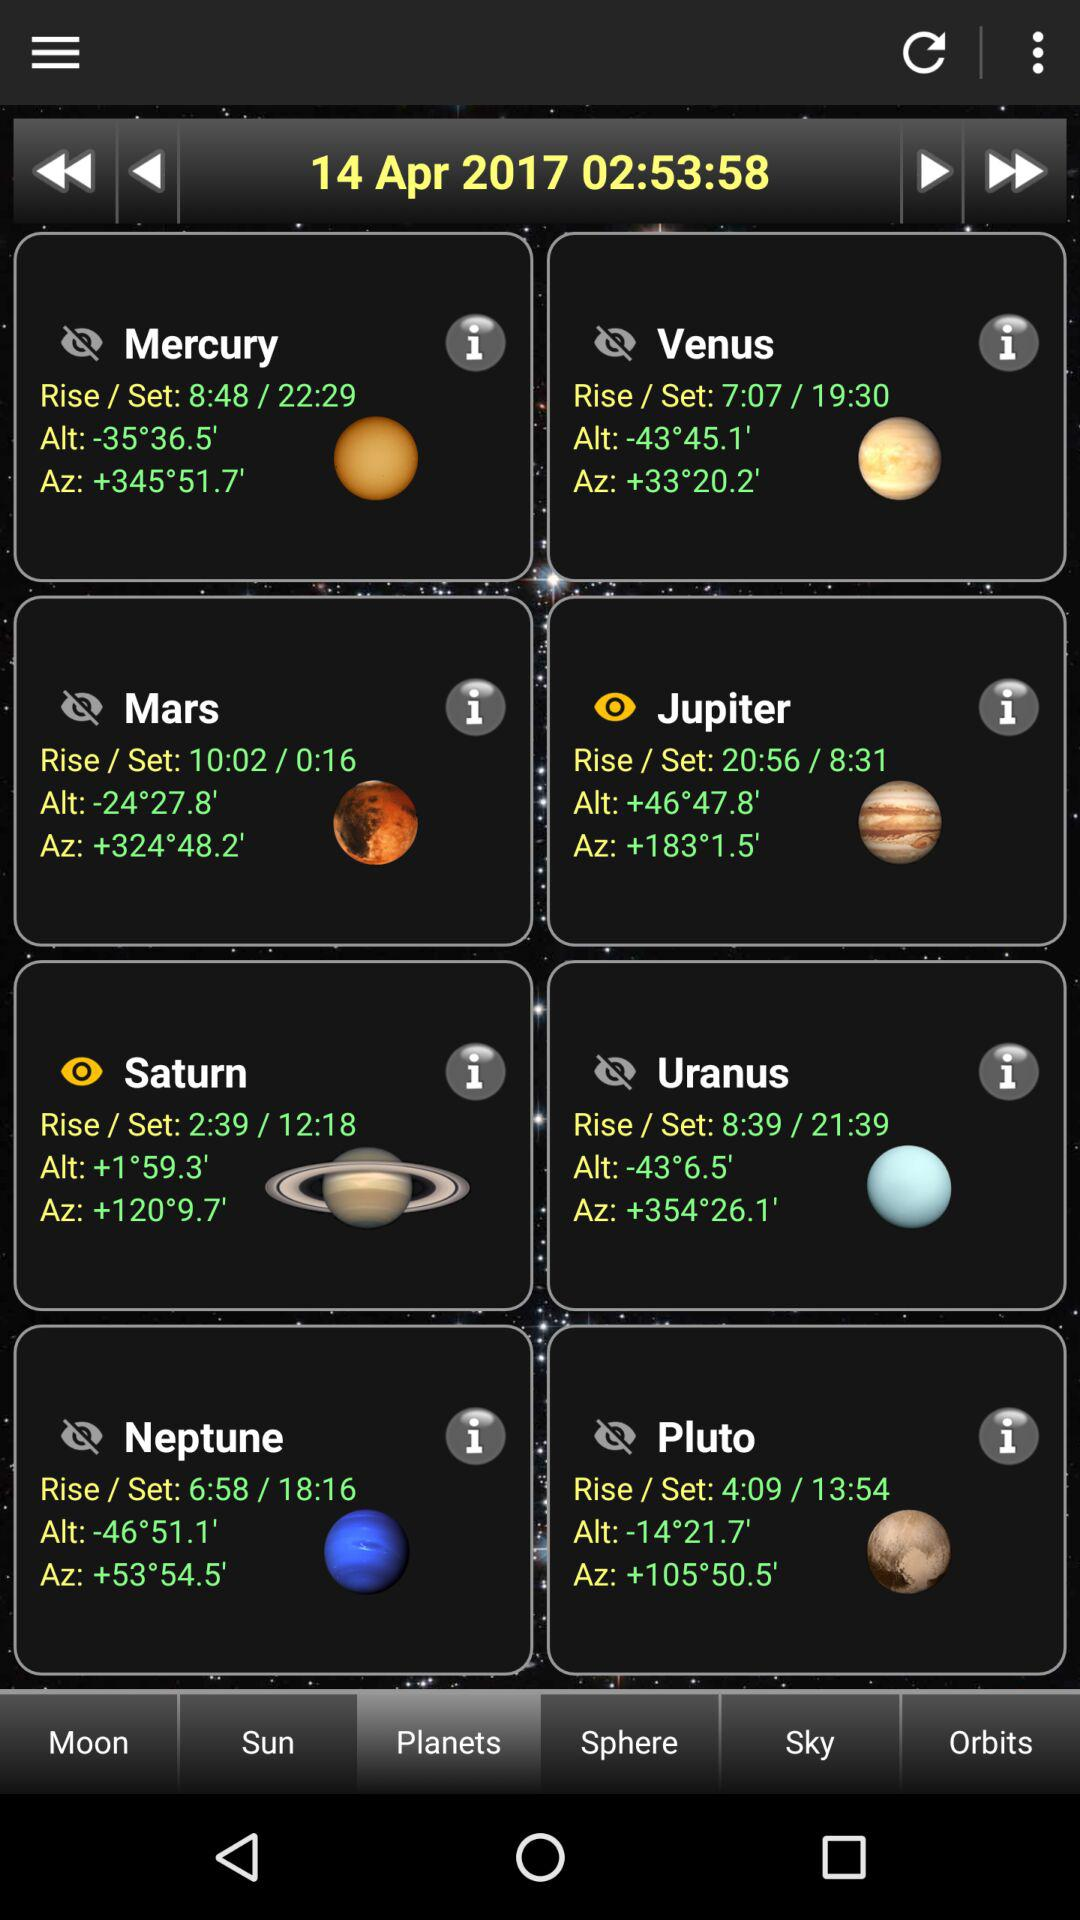What is the rising time of Mars? The rising time of Mars is 10:02. 